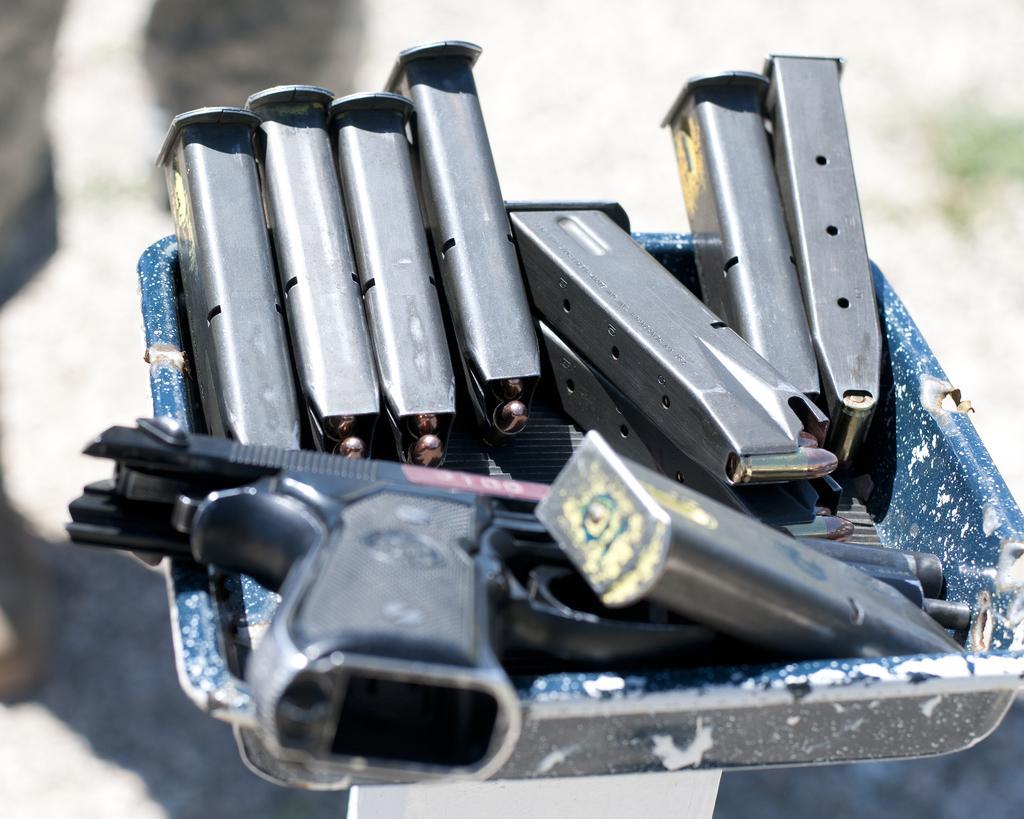Can you describe this image briefly? The picture consists of a tray, in the tray there are magazines, bullets and a gun. The background is blurred. 